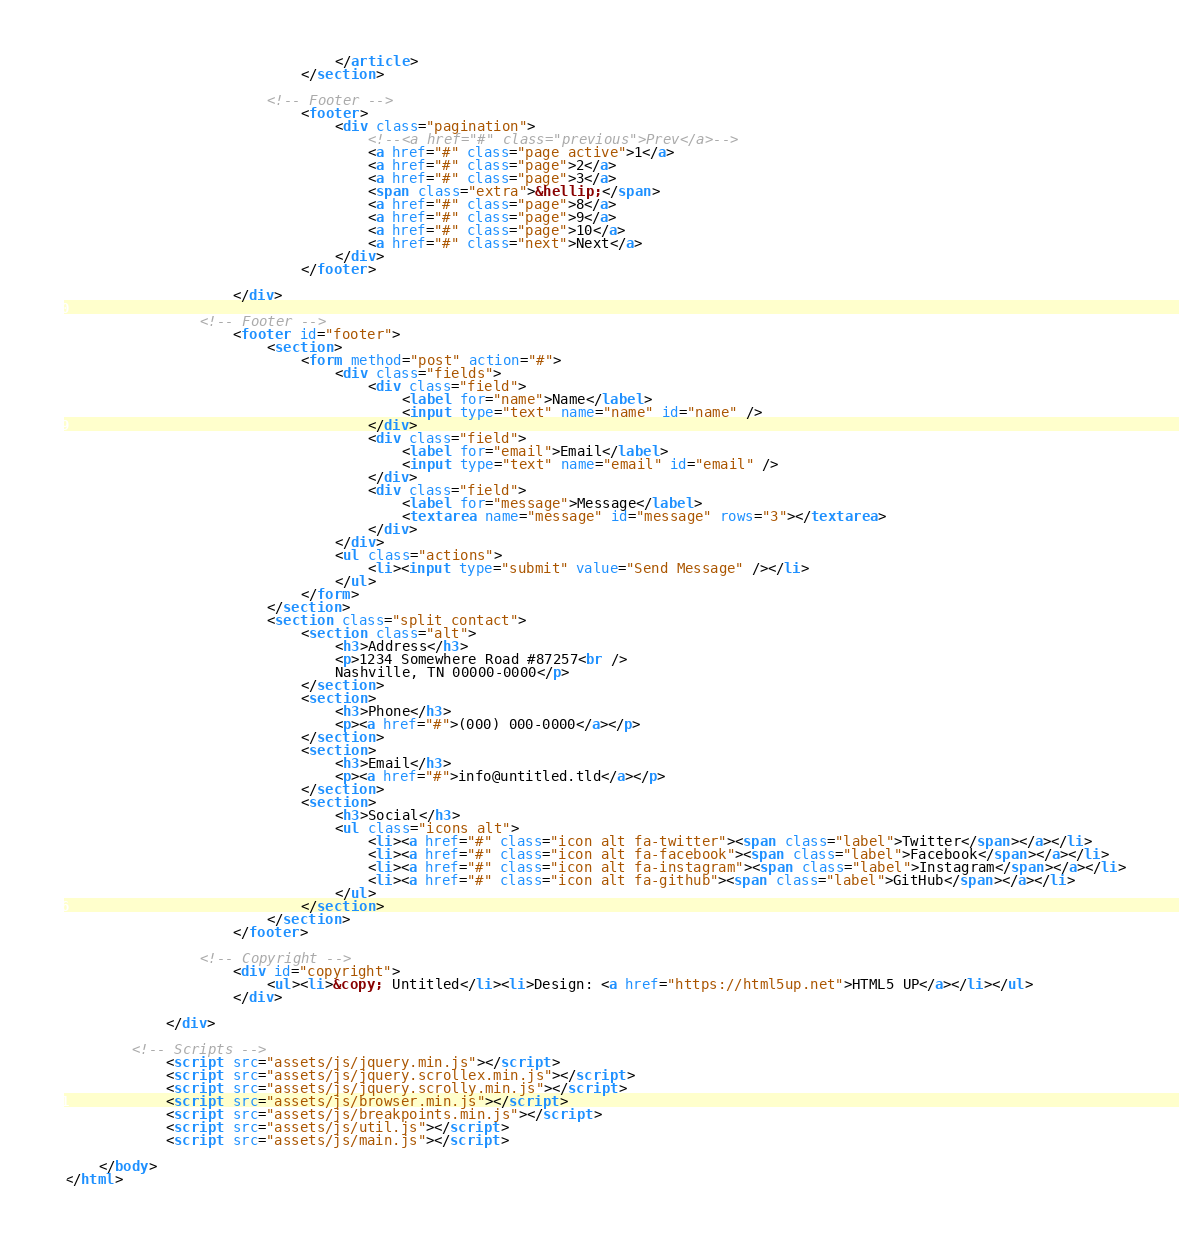<code> <loc_0><loc_0><loc_500><loc_500><_HTML_>								</article>
							</section>

						<!-- Footer -->
							<footer>
								<div class="pagination">
									<!--<a href="#" class="previous">Prev</a>-->
									<a href="#" class="page active">1</a>
									<a href="#" class="page">2</a>
									<a href="#" class="page">3</a>
									<span class="extra">&hellip;</span>
									<a href="#" class="page">8</a>
									<a href="#" class="page">9</a>
									<a href="#" class="page">10</a>
									<a href="#" class="next">Next</a>
								</div>
							</footer>

					</div>

				<!-- Footer -->
					<footer id="footer">
						<section>
							<form method="post" action="#">
								<div class="fields">
									<div class="field">
										<label for="name">Name</label>
										<input type="text" name="name" id="name" />
									</div>
									<div class="field">
										<label for="email">Email</label>
										<input type="text" name="email" id="email" />
									</div>
									<div class="field">
										<label for="message">Message</label>
										<textarea name="message" id="message" rows="3"></textarea>
									</div>
								</div>
								<ul class="actions">
									<li><input type="submit" value="Send Message" /></li>
								</ul>
							</form>
						</section>
						<section class="split contact">
							<section class="alt">
								<h3>Address</h3>
								<p>1234 Somewhere Road #87257<br />
								Nashville, TN 00000-0000</p>
							</section>
							<section>
								<h3>Phone</h3>
								<p><a href="#">(000) 000-0000</a></p>
							</section>
							<section>
								<h3>Email</h3>
								<p><a href="#">info@untitled.tld</a></p>
							</section>
							<section>
								<h3>Social</h3>
								<ul class="icons alt">
									<li><a href="#" class="icon alt fa-twitter"><span class="label">Twitter</span></a></li>
									<li><a href="#" class="icon alt fa-facebook"><span class="label">Facebook</span></a></li>
									<li><a href="#" class="icon alt fa-instagram"><span class="label">Instagram</span></a></li>
									<li><a href="#" class="icon alt fa-github"><span class="label">GitHub</span></a></li>
								</ul>
							</section>
						</section>
					</footer>

				<!-- Copyright -->
					<div id="copyright">
						<ul><li>&copy; Untitled</li><li>Design: <a href="https://html5up.net">HTML5 UP</a></li></ul>
					</div>

			</div>

		<!-- Scripts -->
			<script src="assets/js/jquery.min.js"></script>
			<script src="assets/js/jquery.scrollex.min.js"></script>
			<script src="assets/js/jquery.scrolly.min.js"></script>
			<script src="assets/js/browser.min.js"></script>
			<script src="assets/js/breakpoints.min.js"></script>
			<script src="assets/js/util.js"></script>
			<script src="assets/js/main.js"></script>

	</body>
</html></code> 